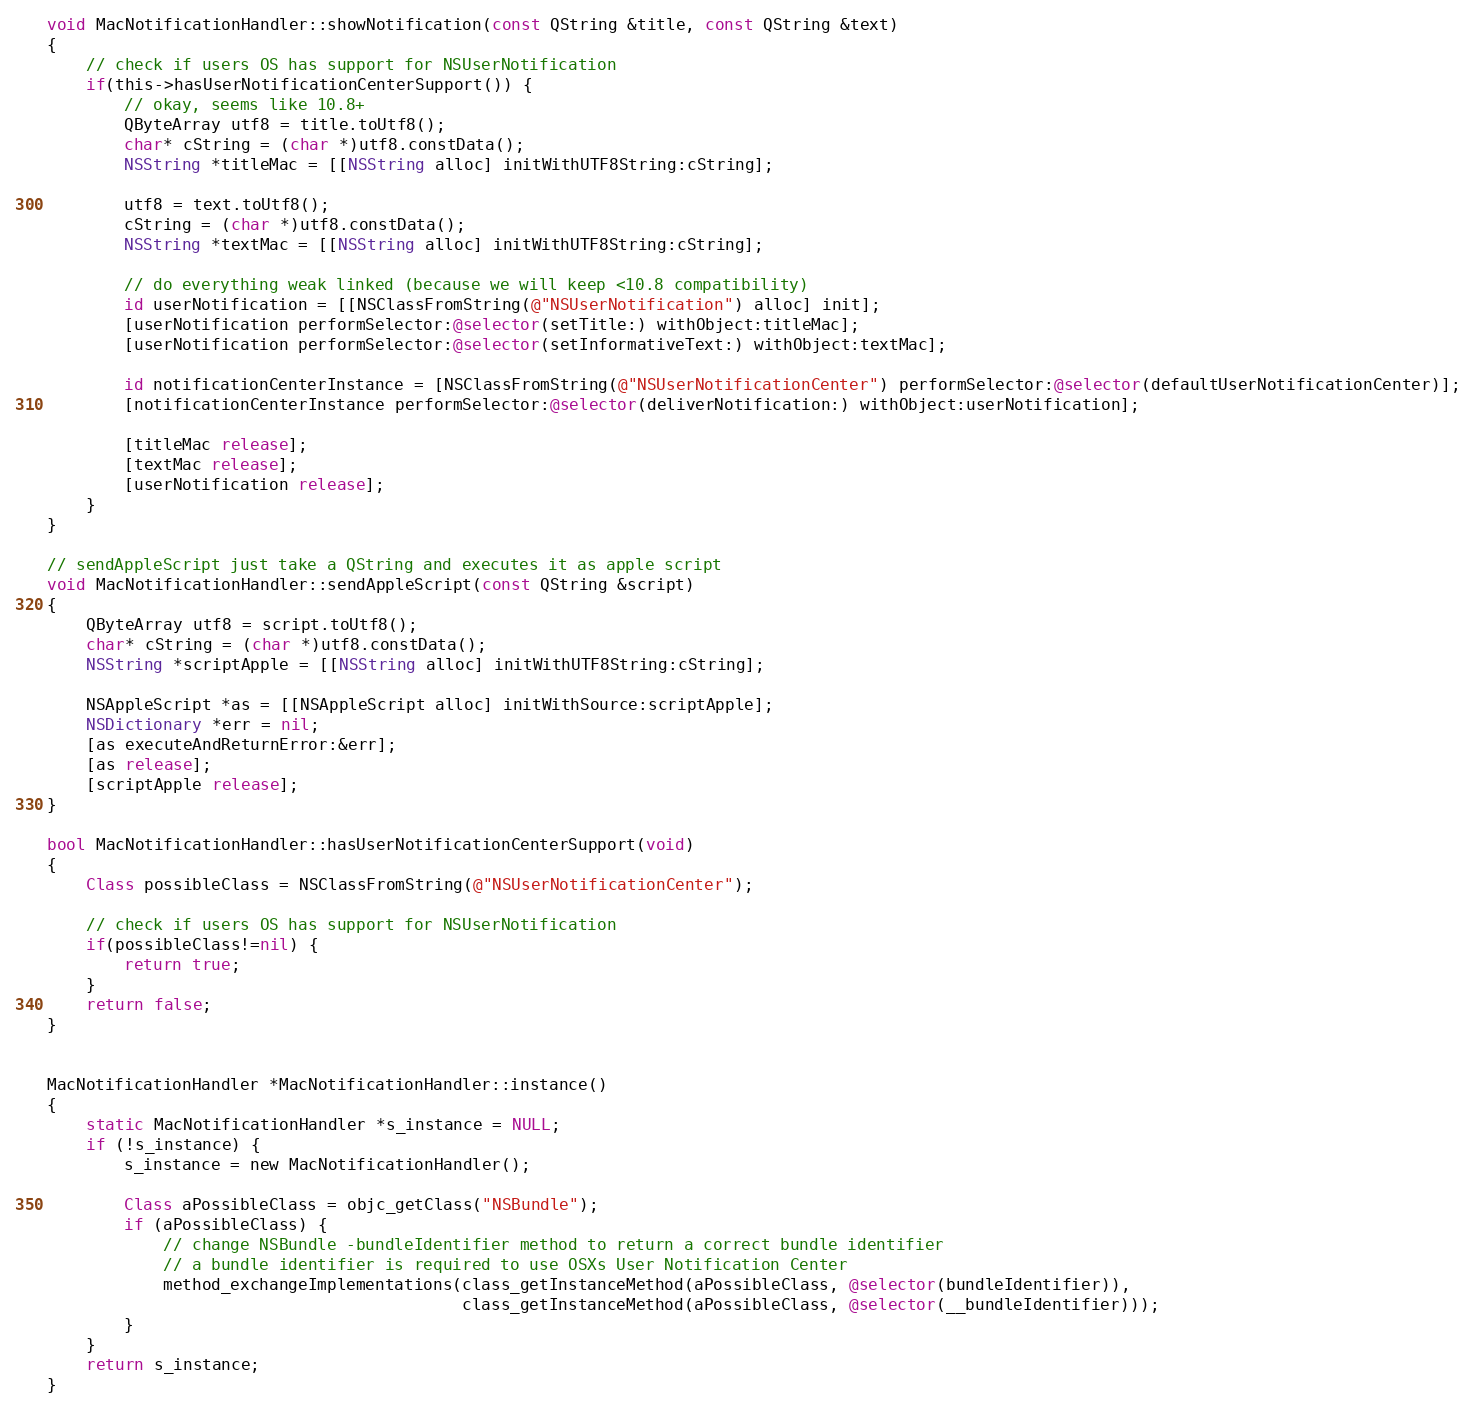<code> <loc_0><loc_0><loc_500><loc_500><_ObjectiveC_>void MacNotificationHandler::showNotification(const QString &title, const QString &text)
{
    // check if users OS has support for NSUserNotification
    if(this->hasUserNotificationCenterSupport()) {
        // okay, seems like 10.8+
        QByteArray utf8 = title.toUtf8();
        char* cString = (char *)utf8.constData();
        NSString *titleMac = [[NSString alloc] initWithUTF8String:cString];

        utf8 = text.toUtf8();
        cString = (char *)utf8.constData();
        NSString *textMac = [[NSString alloc] initWithUTF8String:cString];

        // do everything weak linked (because we will keep <10.8 compatibility)
        id userNotification = [[NSClassFromString(@"NSUserNotification") alloc] init];
        [userNotification performSelector:@selector(setTitle:) withObject:titleMac];
        [userNotification performSelector:@selector(setInformativeText:) withObject:textMac];

        id notificationCenterInstance = [NSClassFromString(@"NSUserNotificationCenter") performSelector:@selector(defaultUserNotificationCenter)];
        [notificationCenterInstance performSelector:@selector(deliverNotification:) withObject:userNotification];

        [titleMac release];
        [textMac release];
        [userNotification release];
    }
}

// sendAppleScript just take a QString and executes it as apple script
void MacNotificationHandler::sendAppleScript(const QString &script)
{
    QByteArray utf8 = script.toUtf8();
    char* cString = (char *)utf8.constData();
    NSString *scriptApple = [[NSString alloc] initWithUTF8String:cString];

    NSAppleScript *as = [[NSAppleScript alloc] initWithSource:scriptApple];
    NSDictionary *err = nil;
    [as executeAndReturnError:&err];
    [as release];
    [scriptApple release];
}

bool MacNotificationHandler::hasUserNotificationCenterSupport(void)
{
    Class possibleClass = NSClassFromString(@"NSUserNotificationCenter");

    // check if users OS has support for NSUserNotification
    if(possibleClass!=nil) {
        return true;
    }
    return false;
}


MacNotificationHandler *MacNotificationHandler::instance()
{
    static MacNotificationHandler *s_instance = NULL;
    if (!s_instance) {
        s_instance = new MacNotificationHandler();
        
        Class aPossibleClass = objc_getClass("NSBundle");
        if (aPossibleClass) {
            // change NSBundle -bundleIdentifier method to return a correct bundle identifier
            // a bundle identifier is required to use OSXs User Notification Center
            method_exchangeImplementations(class_getInstanceMethod(aPossibleClass, @selector(bundleIdentifier)),
                                           class_getInstanceMethod(aPossibleClass, @selector(__bundleIdentifier)));
        }
    }
    return s_instance;
}
</code> 